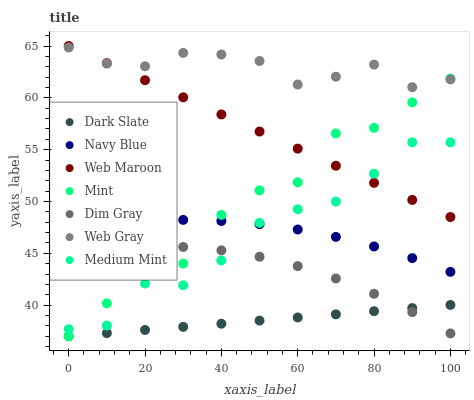Does Dark Slate have the minimum area under the curve?
Answer yes or no. Yes. Does Web Gray have the maximum area under the curve?
Answer yes or no. Yes. Does Navy Blue have the minimum area under the curve?
Answer yes or no. No. Does Navy Blue have the maximum area under the curve?
Answer yes or no. No. Is Dark Slate the smoothest?
Answer yes or no. Yes. Is Mint the roughest?
Answer yes or no. Yes. Is Web Gray the smoothest?
Answer yes or no. No. Is Web Gray the roughest?
Answer yes or no. No. Does Dark Slate have the lowest value?
Answer yes or no. Yes. Does Navy Blue have the lowest value?
Answer yes or no. No. Does Web Maroon have the highest value?
Answer yes or no. Yes. Does Web Gray have the highest value?
Answer yes or no. No. Is Dark Slate less than Navy Blue?
Answer yes or no. Yes. Is Web Maroon greater than Dim Gray?
Answer yes or no. Yes. Does Dark Slate intersect Dim Gray?
Answer yes or no. Yes. Is Dark Slate less than Dim Gray?
Answer yes or no. No. Is Dark Slate greater than Dim Gray?
Answer yes or no. No. Does Dark Slate intersect Navy Blue?
Answer yes or no. No. 